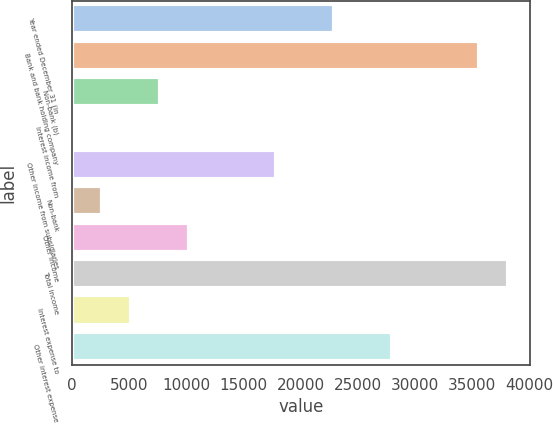Convert chart. <chart><loc_0><loc_0><loc_500><loc_500><bar_chart><fcel>Year ended December 31 (in<fcel>Bank and bank holding company<fcel>Non-bank (b)<fcel>Interest income from<fcel>Other income from subsidiaries<fcel>Non-bank<fcel>Other income<fcel>Total income<fcel>Interest expense to<fcel>Other interest expense<nl><fcel>22954.5<fcel>35667<fcel>7699.5<fcel>72<fcel>17869.5<fcel>2614.5<fcel>10242<fcel>38209.5<fcel>5157<fcel>28039.5<nl></chart> 